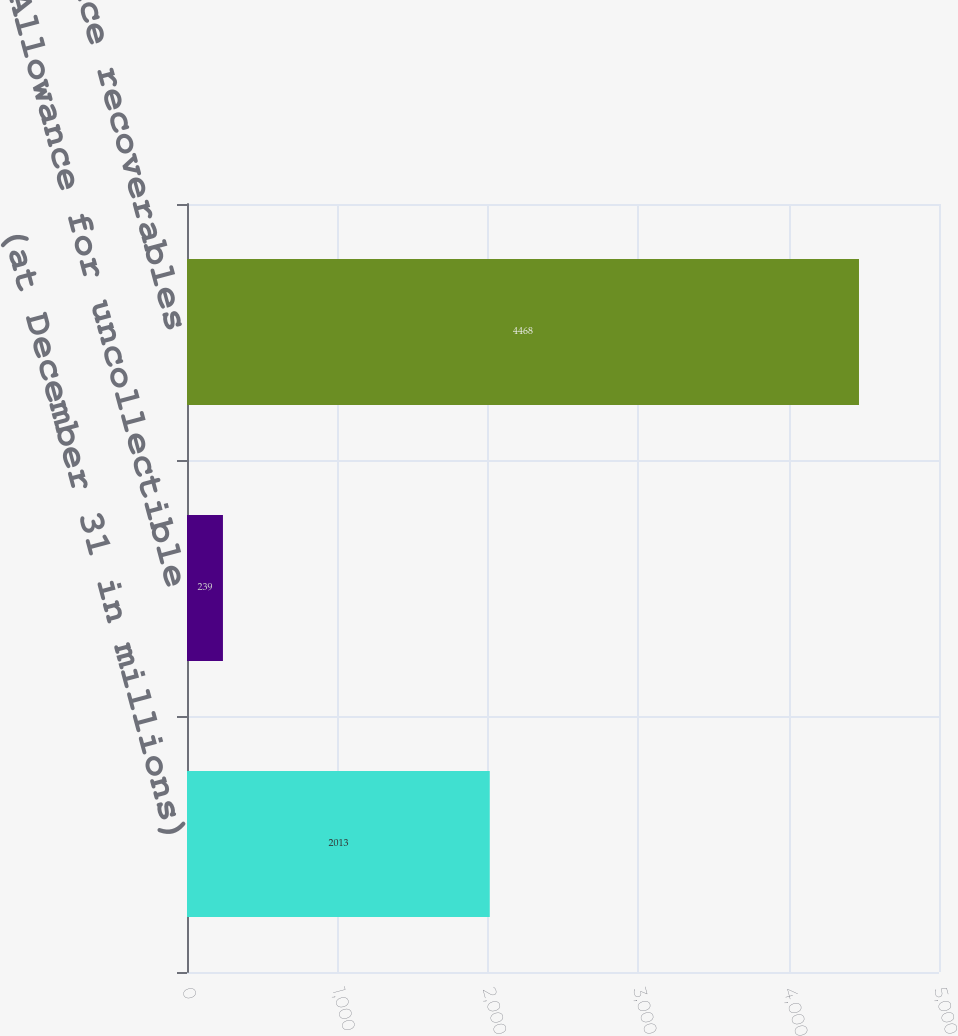Convert chart. <chart><loc_0><loc_0><loc_500><loc_500><bar_chart><fcel>(at December 31 in millions)<fcel>Allowance for uncollectible<fcel>Net reinsurance recoverables<nl><fcel>2013<fcel>239<fcel>4468<nl></chart> 